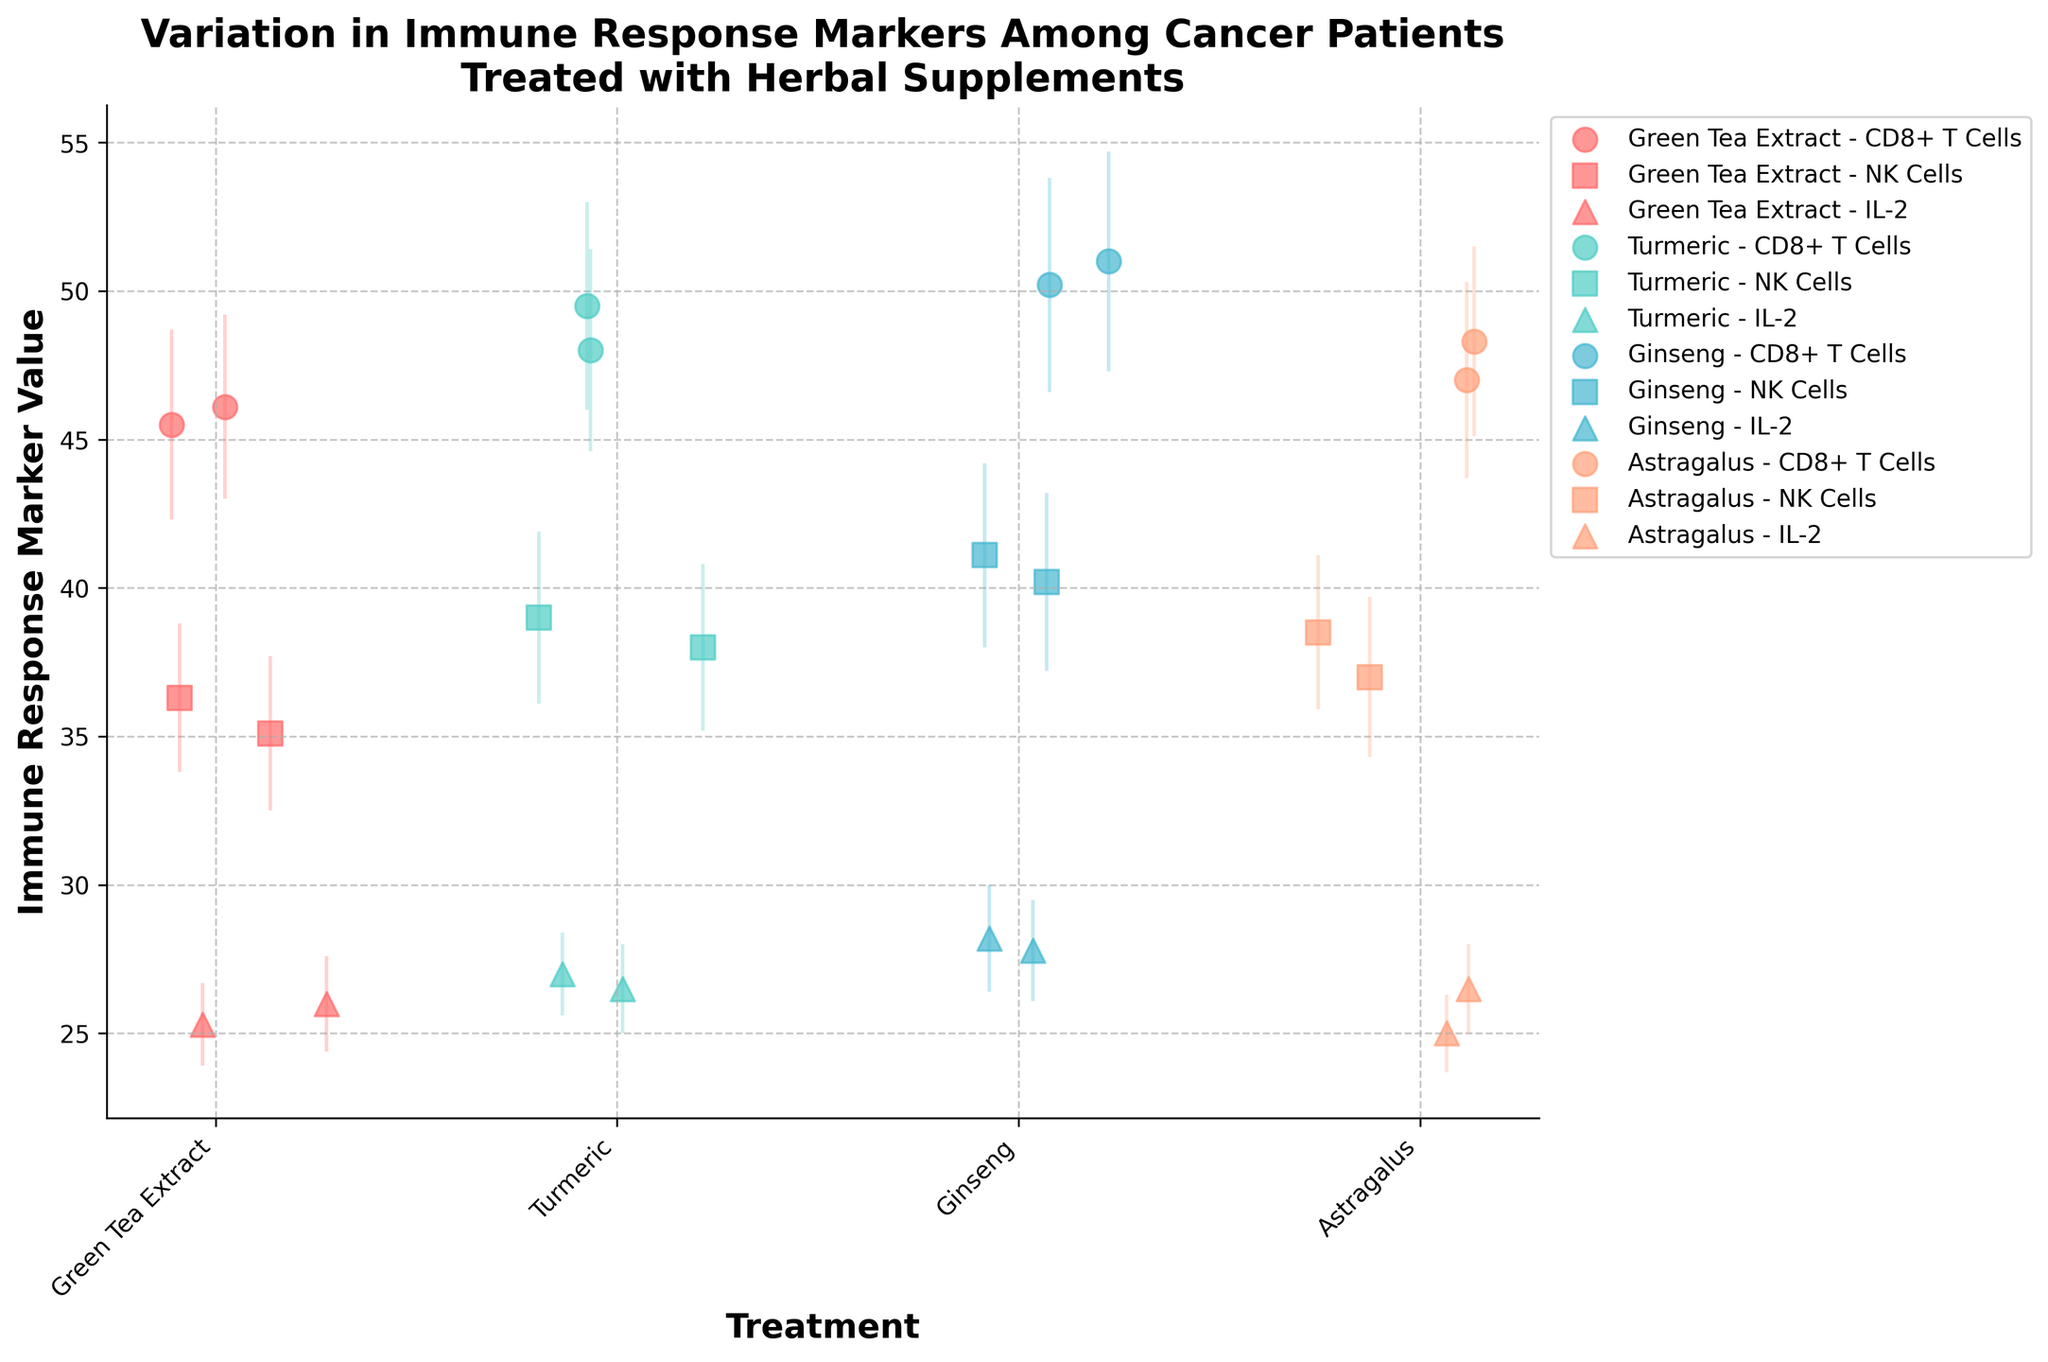What's the title of the figure? Look at the top of the figure to find the title. The title provides an overview of what the figure is about and usually appears in bold.
Answer: Variation in Immune Response Markers Among Cancer Patients Treated with Herbal Supplements What is the x-axis representing? The x-axis typically labels categories or variables being compared. Reading the label directly under the horizontal line will specify this.
Answer: Treatment How many different herbal treatments are shown in the figure? Count the unique categories along the x-axis. Each unique label corresponds to a different herbal treatment.
Answer: Four Which treatment has the highest average value for CD8+ T Cells? Locate all the points representing CD8+ T Cells across the different treatments. Identify the one with the highest average value.
Answer: Ginseng What is the largest standard error (error bar) shown for NK Cells? Check the length of the vertical lines representing the error bars for all the NK Cells data points. The longest line represents the largest standard error.
Answer: 3.1 Which immune marker shows the least variation among the treatments? Compare the standard error bars for each immune marker across all treatments. The markers with the shortest and most consistent error bars show the least variation.
Answer: IL-2 Between Ginseng and Turmeric, which treatment has more consistent (less variable) values for CD8+ T Cells? Look at the standard errors (error bars) for CD8+ T Cells in the Ginseng and Turmeric groups. The treatment with shorter and more consistent error bars is more consistent.
Answer: Turmeric 